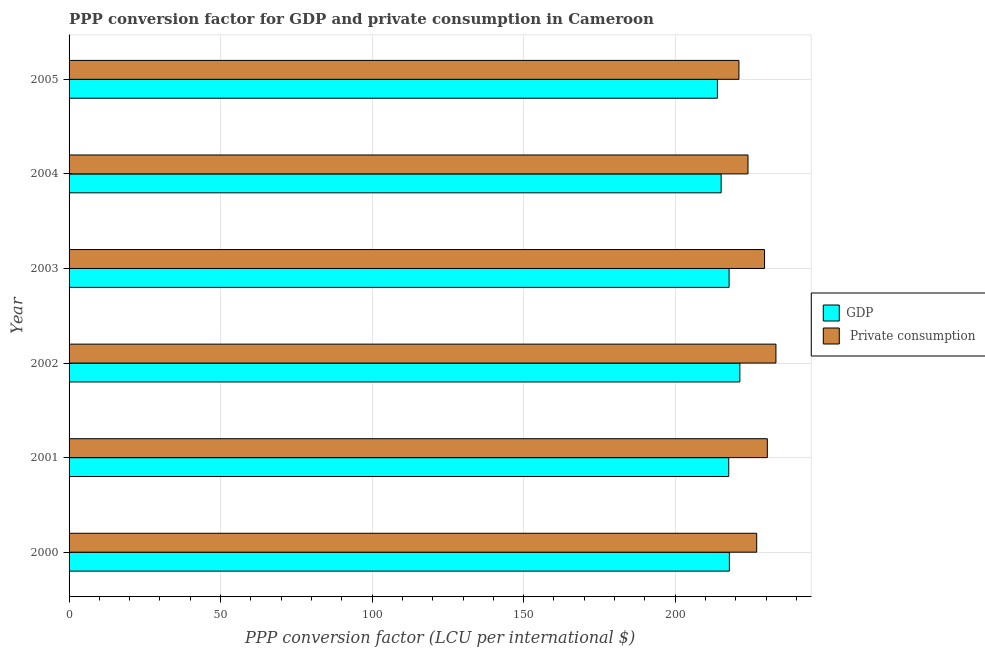How many groups of bars are there?
Your answer should be very brief. 6. Are the number of bars per tick equal to the number of legend labels?
Your answer should be compact. Yes. Are the number of bars on each tick of the Y-axis equal?
Your response must be concise. Yes. How many bars are there on the 1st tick from the top?
Your answer should be very brief. 2. How many bars are there on the 5th tick from the bottom?
Keep it short and to the point. 2. What is the label of the 3rd group of bars from the top?
Make the answer very short. 2003. In how many cases, is the number of bars for a given year not equal to the number of legend labels?
Give a very brief answer. 0. What is the ppp conversion factor for private consumption in 2005?
Your answer should be compact. 221.04. Across all years, what is the maximum ppp conversion factor for gdp?
Offer a very short reply. 221.34. Across all years, what is the minimum ppp conversion factor for private consumption?
Make the answer very short. 221.04. In which year was the ppp conversion factor for private consumption minimum?
Ensure brevity in your answer.  2005. What is the total ppp conversion factor for gdp in the graph?
Keep it short and to the point. 1303.78. What is the difference between the ppp conversion factor for gdp in 2002 and that in 2005?
Keep it short and to the point. 7.41. What is the difference between the ppp conversion factor for gdp in 2000 and the ppp conversion factor for private consumption in 2002?
Your response must be concise. -15.36. What is the average ppp conversion factor for private consumption per year?
Offer a terse response. 227.52. In the year 2002, what is the difference between the ppp conversion factor for private consumption and ppp conversion factor for gdp?
Your answer should be compact. 11.9. What is the difference between the highest and the second highest ppp conversion factor for private consumption?
Provide a succinct answer. 2.83. What is the difference between the highest and the lowest ppp conversion factor for private consumption?
Give a very brief answer. 12.21. What does the 2nd bar from the top in 2004 represents?
Provide a short and direct response. GDP. What does the 2nd bar from the bottom in 2005 represents?
Make the answer very short.  Private consumption. How many bars are there?
Give a very brief answer. 12. Are all the bars in the graph horizontal?
Provide a succinct answer. Yes. How many years are there in the graph?
Make the answer very short. 6. What is the difference between two consecutive major ticks on the X-axis?
Make the answer very short. 50. Does the graph contain any zero values?
Give a very brief answer. No. Does the graph contain grids?
Your answer should be very brief. Yes. Where does the legend appear in the graph?
Your response must be concise. Center right. How many legend labels are there?
Give a very brief answer. 2. What is the title of the graph?
Your response must be concise. PPP conversion factor for GDP and private consumption in Cameroon. What is the label or title of the X-axis?
Offer a terse response. PPP conversion factor (LCU per international $). What is the label or title of the Y-axis?
Your answer should be very brief. Year. What is the PPP conversion factor (LCU per international $) in GDP in 2000?
Keep it short and to the point. 217.88. What is the PPP conversion factor (LCU per international $) in  Private consumption in 2000?
Offer a terse response. 226.9. What is the PPP conversion factor (LCU per international $) of GDP in 2001?
Your answer should be compact. 217.67. What is the PPP conversion factor (LCU per international $) of  Private consumption in 2001?
Make the answer very short. 230.41. What is the PPP conversion factor (LCU per international $) in GDP in 2002?
Your answer should be compact. 221.34. What is the PPP conversion factor (LCU per international $) in  Private consumption in 2002?
Keep it short and to the point. 233.24. What is the PPP conversion factor (LCU per international $) in GDP in 2003?
Ensure brevity in your answer.  217.79. What is the PPP conversion factor (LCU per international $) of  Private consumption in 2003?
Provide a succinct answer. 229.49. What is the PPP conversion factor (LCU per international $) in GDP in 2004?
Ensure brevity in your answer.  215.16. What is the PPP conversion factor (LCU per international $) in  Private consumption in 2004?
Provide a succinct answer. 224.03. What is the PPP conversion factor (LCU per international $) in GDP in 2005?
Your answer should be compact. 213.94. What is the PPP conversion factor (LCU per international $) in  Private consumption in 2005?
Offer a very short reply. 221.04. Across all years, what is the maximum PPP conversion factor (LCU per international $) in GDP?
Provide a succinct answer. 221.34. Across all years, what is the maximum PPP conversion factor (LCU per international $) of  Private consumption?
Make the answer very short. 233.24. Across all years, what is the minimum PPP conversion factor (LCU per international $) of GDP?
Offer a terse response. 213.94. Across all years, what is the minimum PPP conversion factor (LCU per international $) in  Private consumption?
Make the answer very short. 221.04. What is the total PPP conversion factor (LCU per international $) of GDP in the graph?
Your response must be concise. 1303.78. What is the total PPP conversion factor (LCU per international $) in  Private consumption in the graph?
Keep it short and to the point. 1365.1. What is the difference between the PPP conversion factor (LCU per international $) of GDP in 2000 and that in 2001?
Your answer should be compact. 0.21. What is the difference between the PPP conversion factor (LCU per international $) in  Private consumption in 2000 and that in 2001?
Provide a short and direct response. -3.52. What is the difference between the PPP conversion factor (LCU per international $) in GDP in 2000 and that in 2002?
Provide a short and direct response. -3.46. What is the difference between the PPP conversion factor (LCU per international $) of  Private consumption in 2000 and that in 2002?
Make the answer very short. -6.35. What is the difference between the PPP conversion factor (LCU per international $) in GDP in 2000 and that in 2003?
Make the answer very short. 0.09. What is the difference between the PPP conversion factor (LCU per international $) in  Private consumption in 2000 and that in 2003?
Provide a succinct answer. -2.59. What is the difference between the PPP conversion factor (LCU per international $) in GDP in 2000 and that in 2004?
Keep it short and to the point. 2.72. What is the difference between the PPP conversion factor (LCU per international $) in  Private consumption in 2000 and that in 2004?
Provide a succinct answer. 2.87. What is the difference between the PPP conversion factor (LCU per international $) of GDP in 2000 and that in 2005?
Your answer should be compact. 3.95. What is the difference between the PPP conversion factor (LCU per international $) in  Private consumption in 2000 and that in 2005?
Provide a succinct answer. 5.86. What is the difference between the PPP conversion factor (LCU per international $) of GDP in 2001 and that in 2002?
Ensure brevity in your answer.  -3.67. What is the difference between the PPP conversion factor (LCU per international $) in  Private consumption in 2001 and that in 2002?
Your response must be concise. -2.83. What is the difference between the PPP conversion factor (LCU per international $) in GDP in 2001 and that in 2003?
Ensure brevity in your answer.  -0.12. What is the difference between the PPP conversion factor (LCU per international $) of  Private consumption in 2001 and that in 2003?
Provide a short and direct response. 0.92. What is the difference between the PPP conversion factor (LCU per international $) of GDP in 2001 and that in 2004?
Offer a very short reply. 2.51. What is the difference between the PPP conversion factor (LCU per international $) of  Private consumption in 2001 and that in 2004?
Provide a short and direct response. 6.39. What is the difference between the PPP conversion factor (LCU per international $) of GDP in 2001 and that in 2005?
Make the answer very short. 3.73. What is the difference between the PPP conversion factor (LCU per international $) of  Private consumption in 2001 and that in 2005?
Keep it short and to the point. 9.37. What is the difference between the PPP conversion factor (LCU per international $) in GDP in 2002 and that in 2003?
Keep it short and to the point. 3.55. What is the difference between the PPP conversion factor (LCU per international $) of  Private consumption in 2002 and that in 2003?
Offer a terse response. 3.76. What is the difference between the PPP conversion factor (LCU per international $) in GDP in 2002 and that in 2004?
Offer a terse response. 6.18. What is the difference between the PPP conversion factor (LCU per international $) of  Private consumption in 2002 and that in 2004?
Provide a short and direct response. 9.22. What is the difference between the PPP conversion factor (LCU per international $) of GDP in 2002 and that in 2005?
Provide a short and direct response. 7.41. What is the difference between the PPP conversion factor (LCU per international $) of  Private consumption in 2002 and that in 2005?
Give a very brief answer. 12.21. What is the difference between the PPP conversion factor (LCU per international $) in GDP in 2003 and that in 2004?
Offer a very short reply. 2.63. What is the difference between the PPP conversion factor (LCU per international $) in  Private consumption in 2003 and that in 2004?
Your response must be concise. 5.46. What is the difference between the PPP conversion factor (LCU per international $) of GDP in 2003 and that in 2005?
Ensure brevity in your answer.  3.85. What is the difference between the PPP conversion factor (LCU per international $) of  Private consumption in 2003 and that in 2005?
Your answer should be very brief. 8.45. What is the difference between the PPP conversion factor (LCU per international $) in GDP in 2004 and that in 2005?
Your answer should be compact. 1.22. What is the difference between the PPP conversion factor (LCU per international $) of  Private consumption in 2004 and that in 2005?
Provide a short and direct response. 2.99. What is the difference between the PPP conversion factor (LCU per international $) of GDP in 2000 and the PPP conversion factor (LCU per international $) of  Private consumption in 2001?
Provide a short and direct response. -12.53. What is the difference between the PPP conversion factor (LCU per international $) of GDP in 2000 and the PPP conversion factor (LCU per international $) of  Private consumption in 2002?
Your answer should be very brief. -15.36. What is the difference between the PPP conversion factor (LCU per international $) of GDP in 2000 and the PPP conversion factor (LCU per international $) of  Private consumption in 2003?
Your answer should be compact. -11.6. What is the difference between the PPP conversion factor (LCU per international $) in GDP in 2000 and the PPP conversion factor (LCU per international $) in  Private consumption in 2004?
Keep it short and to the point. -6.14. What is the difference between the PPP conversion factor (LCU per international $) in GDP in 2000 and the PPP conversion factor (LCU per international $) in  Private consumption in 2005?
Your answer should be very brief. -3.15. What is the difference between the PPP conversion factor (LCU per international $) in GDP in 2001 and the PPP conversion factor (LCU per international $) in  Private consumption in 2002?
Make the answer very short. -15.57. What is the difference between the PPP conversion factor (LCU per international $) of GDP in 2001 and the PPP conversion factor (LCU per international $) of  Private consumption in 2003?
Provide a short and direct response. -11.82. What is the difference between the PPP conversion factor (LCU per international $) in GDP in 2001 and the PPP conversion factor (LCU per international $) in  Private consumption in 2004?
Make the answer very short. -6.36. What is the difference between the PPP conversion factor (LCU per international $) in GDP in 2001 and the PPP conversion factor (LCU per international $) in  Private consumption in 2005?
Offer a very short reply. -3.37. What is the difference between the PPP conversion factor (LCU per international $) in GDP in 2002 and the PPP conversion factor (LCU per international $) in  Private consumption in 2003?
Ensure brevity in your answer.  -8.15. What is the difference between the PPP conversion factor (LCU per international $) of GDP in 2002 and the PPP conversion factor (LCU per international $) of  Private consumption in 2004?
Offer a very short reply. -2.68. What is the difference between the PPP conversion factor (LCU per international $) of GDP in 2002 and the PPP conversion factor (LCU per international $) of  Private consumption in 2005?
Offer a very short reply. 0.3. What is the difference between the PPP conversion factor (LCU per international $) in GDP in 2003 and the PPP conversion factor (LCU per international $) in  Private consumption in 2004?
Provide a short and direct response. -6.24. What is the difference between the PPP conversion factor (LCU per international $) in GDP in 2003 and the PPP conversion factor (LCU per international $) in  Private consumption in 2005?
Provide a short and direct response. -3.25. What is the difference between the PPP conversion factor (LCU per international $) in GDP in 2004 and the PPP conversion factor (LCU per international $) in  Private consumption in 2005?
Make the answer very short. -5.88. What is the average PPP conversion factor (LCU per international $) in GDP per year?
Ensure brevity in your answer.  217.3. What is the average PPP conversion factor (LCU per international $) in  Private consumption per year?
Your response must be concise. 227.52. In the year 2000, what is the difference between the PPP conversion factor (LCU per international $) in GDP and PPP conversion factor (LCU per international $) in  Private consumption?
Provide a succinct answer. -9.01. In the year 2001, what is the difference between the PPP conversion factor (LCU per international $) of GDP and PPP conversion factor (LCU per international $) of  Private consumption?
Your response must be concise. -12.74. In the year 2002, what is the difference between the PPP conversion factor (LCU per international $) of GDP and PPP conversion factor (LCU per international $) of  Private consumption?
Your answer should be compact. -11.9. In the year 2003, what is the difference between the PPP conversion factor (LCU per international $) in GDP and PPP conversion factor (LCU per international $) in  Private consumption?
Your answer should be compact. -11.7. In the year 2004, what is the difference between the PPP conversion factor (LCU per international $) of GDP and PPP conversion factor (LCU per international $) of  Private consumption?
Offer a very short reply. -8.87. In the year 2005, what is the difference between the PPP conversion factor (LCU per international $) in GDP and PPP conversion factor (LCU per international $) in  Private consumption?
Give a very brief answer. -7.1. What is the ratio of the PPP conversion factor (LCU per international $) of GDP in 2000 to that in 2001?
Provide a short and direct response. 1. What is the ratio of the PPP conversion factor (LCU per international $) of  Private consumption in 2000 to that in 2001?
Your answer should be compact. 0.98. What is the ratio of the PPP conversion factor (LCU per international $) in GDP in 2000 to that in 2002?
Your response must be concise. 0.98. What is the ratio of the PPP conversion factor (LCU per international $) in  Private consumption in 2000 to that in 2002?
Give a very brief answer. 0.97. What is the ratio of the PPP conversion factor (LCU per international $) in GDP in 2000 to that in 2003?
Give a very brief answer. 1. What is the ratio of the PPP conversion factor (LCU per international $) of  Private consumption in 2000 to that in 2003?
Your answer should be very brief. 0.99. What is the ratio of the PPP conversion factor (LCU per international $) in GDP in 2000 to that in 2004?
Your answer should be very brief. 1.01. What is the ratio of the PPP conversion factor (LCU per international $) of  Private consumption in 2000 to that in 2004?
Give a very brief answer. 1.01. What is the ratio of the PPP conversion factor (LCU per international $) of GDP in 2000 to that in 2005?
Offer a very short reply. 1.02. What is the ratio of the PPP conversion factor (LCU per international $) of  Private consumption in 2000 to that in 2005?
Offer a very short reply. 1.03. What is the ratio of the PPP conversion factor (LCU per international $) in GDP in 2001 to that in 2002?
Provide a succinct answer. 0.98. What is the ratio of the PPP conversion factor (LCU per international $) in  Private consumption in 2001 to that in 2002?
Offer a terse response. 0.99. What is the ratio of the PPP conversion factor (LCU per international $) in GDP in 2001 to that in 2004?
Provide a short and direct response. 1.01. What is the ratio of the PPP conversion factor (LCU per international $) in  Private consumption in 2001 to that in 2004?
Make the answer very short. 1.03. What is the ratio of the PPP conversion factor (LCU per international $) of GDP in 2001 to that in 2005?
Keep it short and to the point. 1.02. What is the ratio of the PPP conversion factor (LCU per international $) of  Private consumption in 2001 to that in 2005?
Give a very brief answer. 1.04. What is the ratio of the PPP conversion factor (LCU per international $) in GDP in 2002 to that in 2003?
Make the answer very short. 1.02. What is the ratio of the PPP conversion factor (LCU per international $) of  Private consumption in 2002 to that in 2003?
Provide a succinct answer. 1.02. What is the ratio of the PPP conversion factor (LCU per international $) in GDP in 2002 to that in 2004?
Offer a terse response. 1.03. What is the ratio of the PPP conversion factor (LCU per international $) in  Private consumption in 2002 to that in 2004?
Make the answer very short. 1.04. What is the ratio of the PPP conversion factor (LCU per international $) of GDP in 2002 to that in 2005?
Your answer should be compact. 1.03. What is the ratio of the PPP conversion factor (LCU per international $) in  Private consumption in 2002 to that in 2005?
Provide a succinct answer. 1.06. What is the ratio of the PPP conversion factor (LCU per international $) of GDP in 2003 to that in 2004?
Provide a short and direct response. 1.01. What is the ratio of the PPP conversion factor (LCU per international $) of  Private consumption in 2003 to that in 2004?
Give a very brief answer. 1.02. What is the ratio of the PPP conversion factor (LCU per international $) in  Private consumption in 2003 to that in 2005?
Give a very brief answer. 1.04. What is the ratio of the PPP conversion factor (LCU per international $) in  Private consumption in 2004 to that in 2005?
Your response must be concise. 1.01. What is the difference between the highest and the second highest PPP conversion factor (LCU per international $) in GDP?
Provide a short and direct response. 3.46. What is the difference between the highest and the second highest PPP conversion factor (LCU per international $) in  Private consumption?
Keep it short and to the point. 2.83. What is the difference between the highest and the lowest PPP conversion factor (LCU per international $) in GDP?
Ensure brevity in your answer.  7.41. What is the difference between the highest and the lowest PPP conversion factor (LCU per international $) in  Private consumption?
Offer a very short reply. 12.21. 